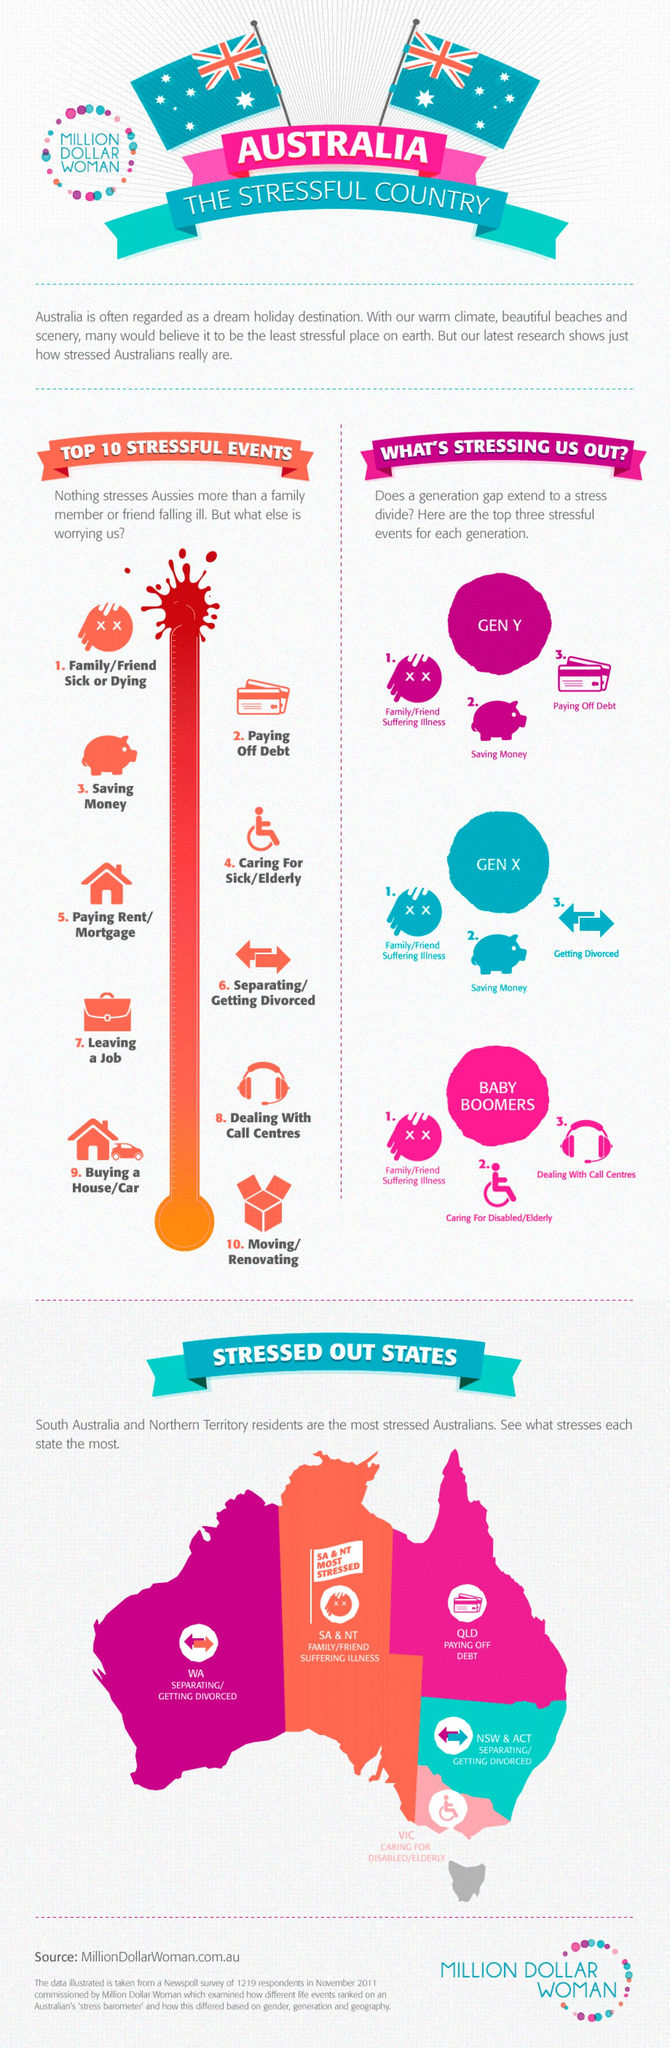Mention a couple of crucial points in this snapshot. The dark pink circle contains the labels Gen X, Baby Boomers, or Gen Y. The text inside the circle indicates that the label "Gen Y" is written inside the circle. The text contained within the light pink circle reads 'Baby Boomers'. There are 5 stressed out states in Australia. The written text within the blue circle is labeled as 'Gen X', indicating the generation to which it belongs. 